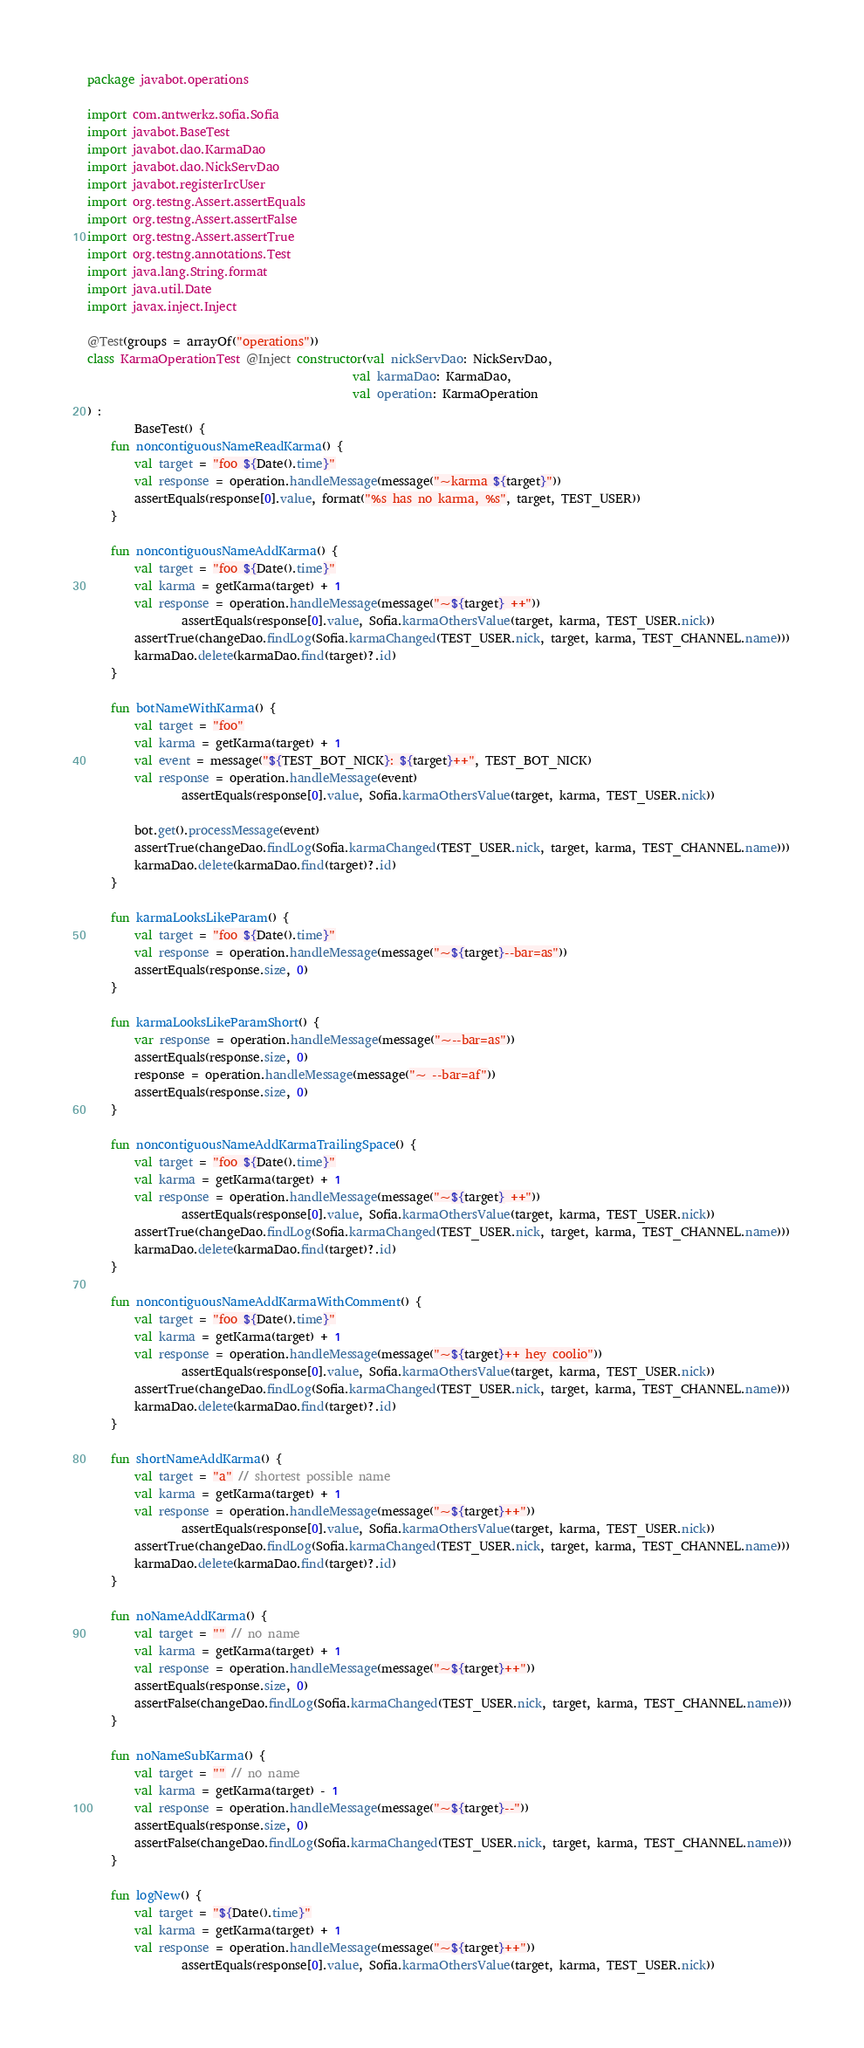Convert code to text. <code><loc_0><loc_0><loc_500><loc_500><_Kotlin_>package javabot.operations

import com.antwerkz.sofia.Sofia
import javabot.BaseTest
import javabot.dao.KarmaDao
import javabot.dao.NickServDao
import javabot.registerIrcUser
import org.testng.Assert.assertEquals
import org.testng.Assert.assertFalse
import org.testng.Assert.assertTrue
import org.testng.annotations.Test
import java.lang.String.format
import java.util.Date
import javax.inject.Inject

@Test(groups = arrayOf("operations"))
class KarmaOperationTest @Inject constructor(val nickServDao: NickServDao,
                                             val karmaDao: KarmaDao,
                                             val operation: KarmaOperation
) :
        BaseTest() {
    fun noncontiguousNameReadKarma() {
        val target = "foo ${Date().time}"
        val response = operation.handleMessage(message("~karma ${target}"))
        assertEquals(response[0].value, format("%s has no karma, %s", target, TEST_USER))
    }

    fun noncontiguousNameAddKarma() {
        val target = "foo ${Date().time}"
        val karma = getKarma(target) + 1
        val response = operation.handleMessage(message("~${target} ++"))
                assertEquals(response[0].value, Sofia.karmaOthersValue(target, karma, TEST_USER.nick))
        assertTrue(changeDao.findLog(Sofia.karmaChanged(TEST_USER.nick, target, karma, TEST_CHANNEL.name)))
        karmaDao.delete(karmaDao.find(target)?.id)
    }

    fun botNameWithKarma() {
        val target = "foo"
        val karma = getKarma(target) + 1
        val event = message("${TEST_BOT_NICK}: ${target}++", TEST_BOT_NICK)
        val response = operation.handleMessage(event)
                assertEquals(response[0].value, Sofia.karmaOthersValue(target, karma, TEST_USER.nick))

        bot.get().processMessage(event)
        assertTrue(changeDao.findLog(Sofia.karmaChanged(TEST_USER.nick, target, karma, TEST_CHANNEL.name)))
        karmaDao.delete(karmaDao.find(target)?.id)
    }

    fun karmaLooksLikeParam() {
        val target = "foo ${Date().time}"
        val response = operation.handleMessage(message("~${target}--bar=as"))
        assertEquals(response.size, 0)
    }

    fun karmaLooksLikeParamShort() {
        var response = operation.handleMessage(message("~--bar=as"))
        assertEquals(response.size, 0)
        response = operation.handleMessage(message("~ --bar=af"))
        assertEquals(response.size, 0)
    }

    fun noncontiguousNameAddKarmaTrailingSpace() {
        val target = "foo ${Date().time}"
        val karma = getKarma(target) + 1
        val response = operation.handleMessage(message("~${target} ++"))
                assertEquals(response[0].value, Sofia.karmaOthersValue(target, karma, TEST_USER.nick))
        assertTrue(changeDao.findLog(Sofia.karmaChanged(TEST_USER.nick, target, karma, TEST_CHANNEL.name)))
        karmaDao.delete(karmaDao.find(target)?.id)
    }

    fun noncontiguousNameAddKarmaWithComment() {
        val target = "foo ${Date().time}"
        val karma = getKarma(target) + 1
        val response = operation.handleMessage(message("~${target}++ hey coolio"))
                assertEquals(response[0].value, Sofia.karmaOthersValue(target, karma, TEST_USER.nick))
        assertTrue(changeDao.findLog(Sofia.karmaChanged(TEST_USER.nick, target, karma, TEST_CHANNEL.name)))
        karmaDao.delete(karmaDao.find(target)?.id)
    }

    fun shortNameAddKarma() {
        val target = "a" // shortest possible name
        val karma = getKarma(target) + 1
        val response = operation.handleMessage(message("~${target}++"))
                assertEquals(response[0].value, Sofia.karmaOthersValue(target, karma, TEST_USER.nick))
        assertTrue(changeDao.findLog(Sofia.karmaChanged(TEST_USER.nick, target, karma, TEST_CHANNEL.name)))
        karmaDao.delete(karmaDao.find(target)?.id)
    }

    fun noNameAddKarma() {
        val target = "" // no name
        val karma = getKarma(target) + 1
        val response = operation.handleMessage(message("~${target}++"))
        assertEquals(response.size, 0)
        assertFalse(changeDao.findLog(Sofia.karmaChanged(TEST_USER.nick, target, karma, TEST_CHANNEL.name)))
    }

    fun noNameSubKarma() {
        val target = "" // no name
        val karma = getKarma(target) - 1
        val response = operation.handleMessage(message("~${target}--"))
        assertEquals(response.size, 0)
        assertFalse(changeDao.findLog(Sofia.karmaChanged(TEST_USER.nick, target, karma, TEST_CHANNEL.name)))
    }

    fun logNew() {
        val target = "${Date().time}"
        val karma = getKarma(target) + 1
        val response = operation.handleMessage(message("~${target}++"))
                assertEquals(response[0].value, Sofia.karmaOthersValue(target, karma, TEST_USER.nick))</code> 